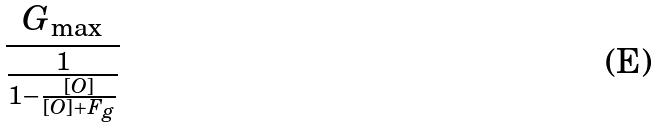Convert formula to latex. <formula><loc_0><loc_0><loc_500><loc_500>\frac { G _ { \max } } { \frac { 1 } { 1 - \frac { [ O ] } { [ O ] + F _ { g } } } }</formula> 